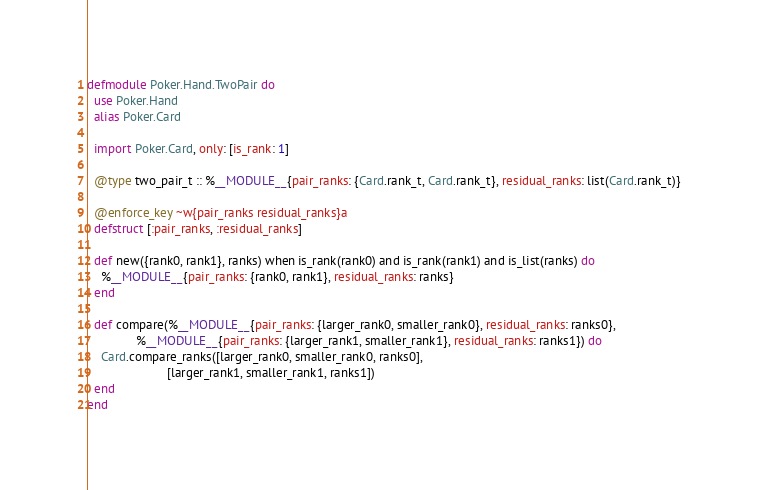Convert code to text. <code><loc_0><loc_0><loc_500><loc_500><_Elixir_>defmodule Poker.Hand.TwoPair do
  use Poker.Hand
  alias Poker.Card

  import Poker.Card, only: [is_rank: 1]

  @type two_pair_t :: %__MODULE__{pair_ranks: {Card.rank_t, Card.rank_t}, residual_ranks: list(Card.rank_t)}

  @enforce_key ~w{pair_ranks residual_ranks}a
  defstruct [:pair_ranks, :residual_ranks]

  def new({rank0, rank1}, ranks) when is_rank(rank0) and is_rank(rank1) and is_list(ranks) do
    %__MODULE__{pair_ranks: {rank0, rank1}, residual_ranks: ranks}
  end

  def compare(%__MODULE__{pair_ranks: {larger_rank0, smaller_rank0}, residual_ranks: ranks0},
              %__MODULE__{pair_ranks: {larger_rank1, smaller_rank1}, residual_ranks: ranks1}) do
    Card.compare_ranks([larger_rank0, smaller_rank0, ranks0],
                       [larger_rank1, smaller_rank1, ranks1])
  end
end
</code> 